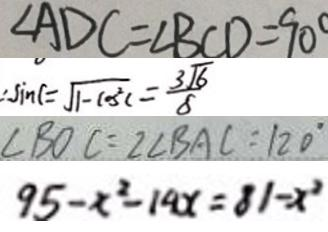Convert formula to latex. <formula><loc_0><loc_0><loc_500><loc_500>\angle A D C = \angle B C D = 9 0 ^ { \circ } 
 \therefore \sin C = \sqrt { 1 - \cos ^ { 2 } C } = \frac { 3 \sqrt { 6 } } { 8 } 
 \angle B O C = 2 \angle B A C = 1 2 0 ^ { \circ } 
 9 5 - x ^ { 2 } - 1 9 x = 8 1 - x ^ { 2 }</formula> 